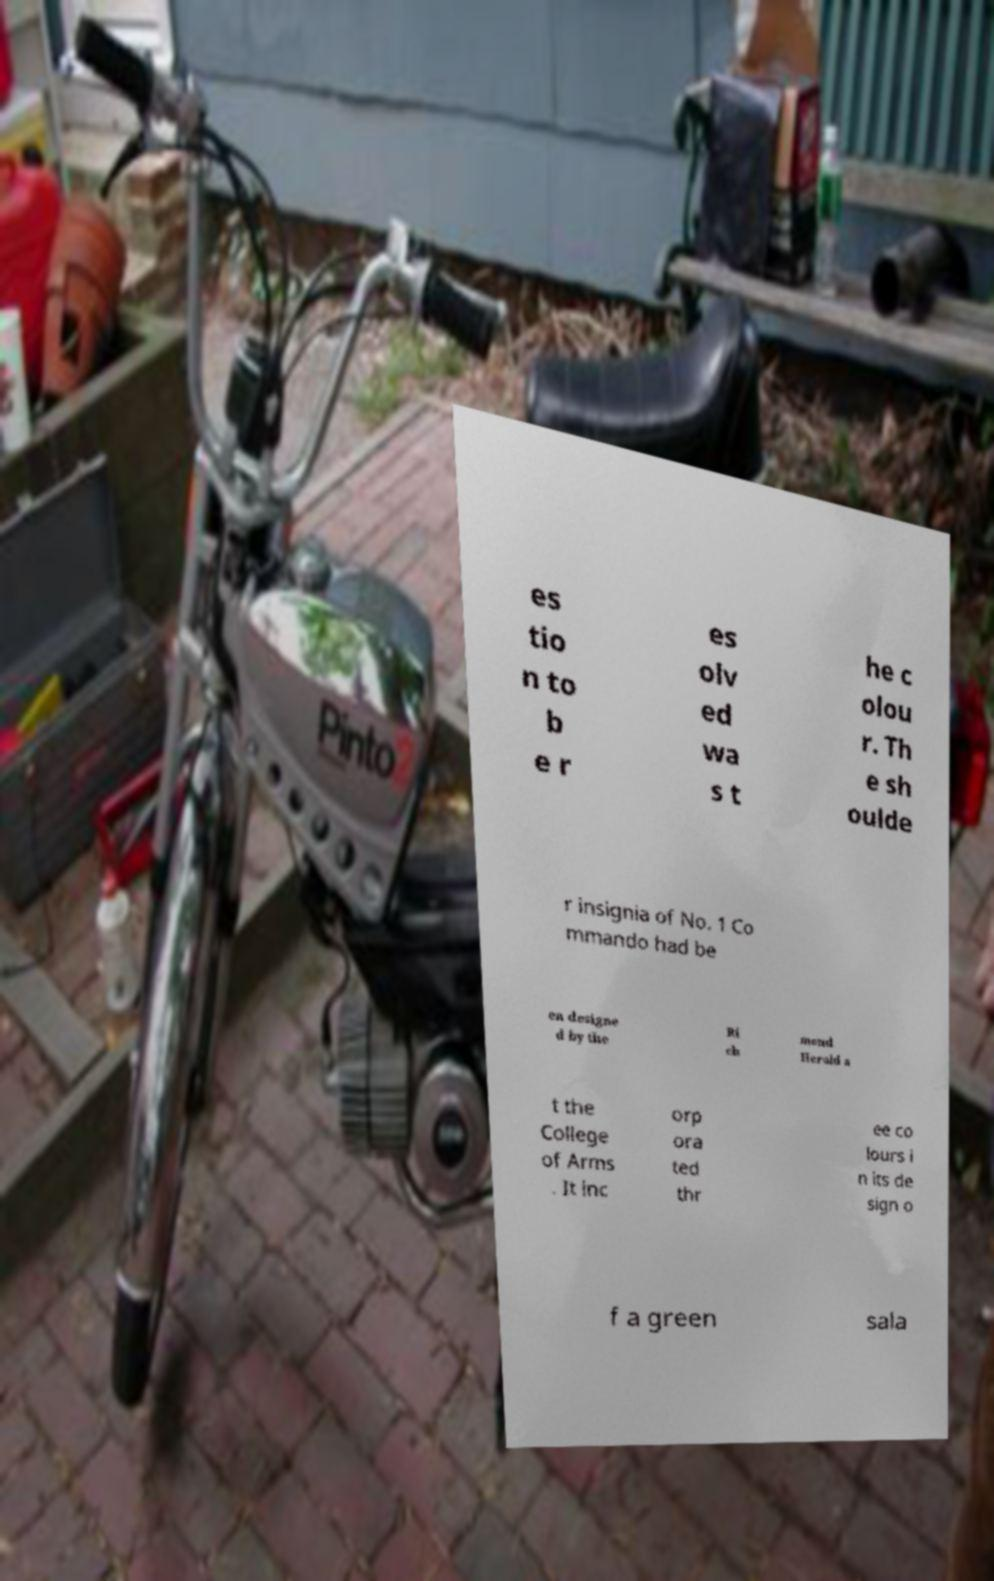Please identify and transcribe the text found in this image. es tio n to b e r es olv ed wa s t he c olou r. Th e sh oulde r insignia of No. 1 Co mmando had be en designe d by the Ri ch mond Herald a t the College of Arms . It inc orp ora ted thr ee co lours i n its de sign o f a green sala 